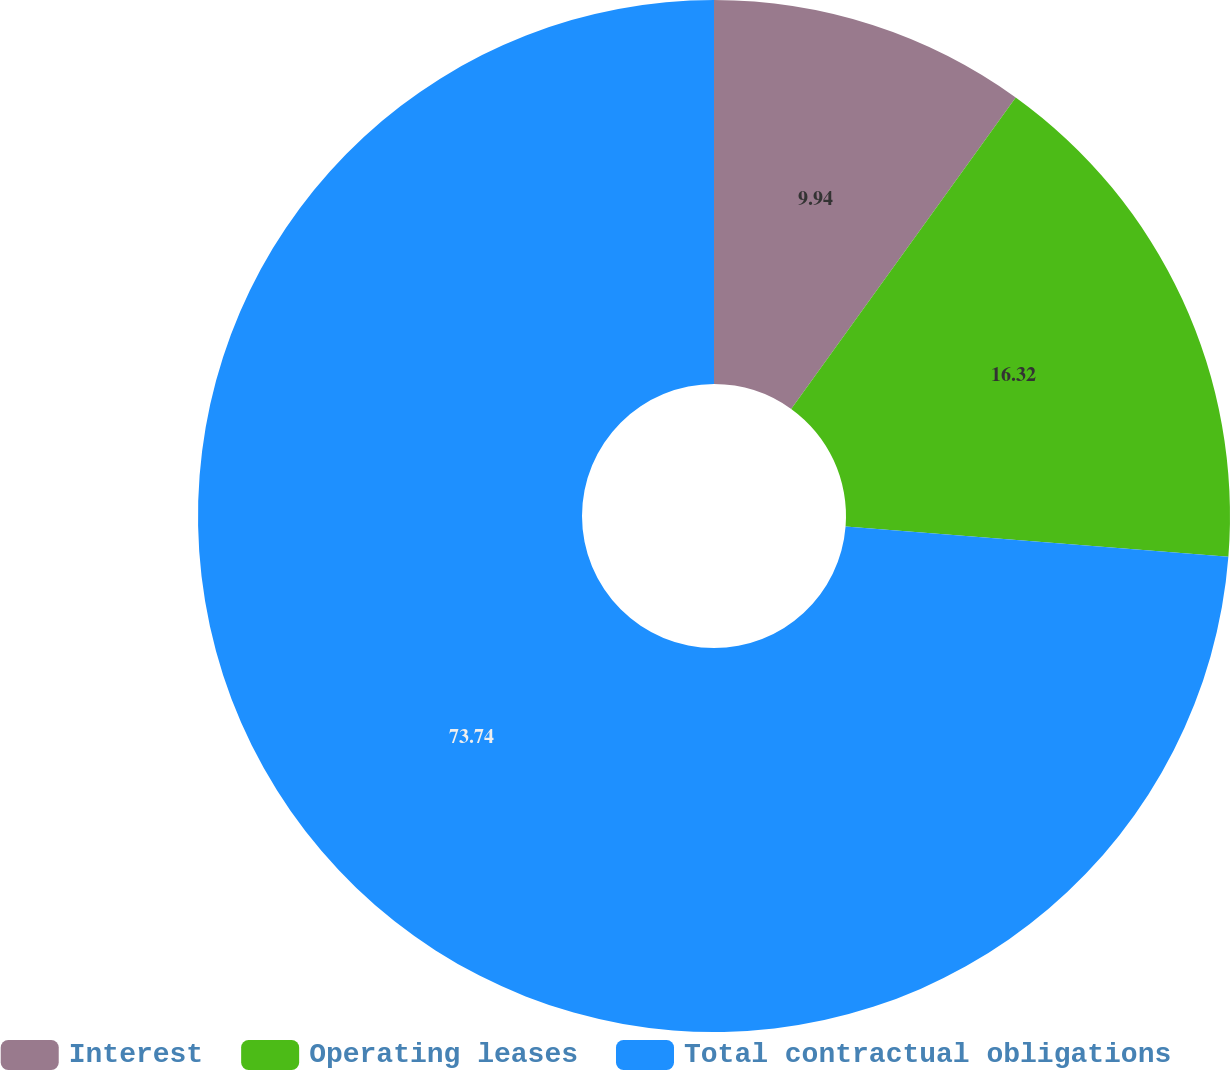Convert chart to OTSL. <chart><loc_0><loc_0><loc_500><loc_500><pie_chart><fcel>Interest<fcel>Operating leases<fcel>Total contractual obligations<nl><fcel>9.94%<fcel>16.32%<fcel>73.74%<nl></chart> 